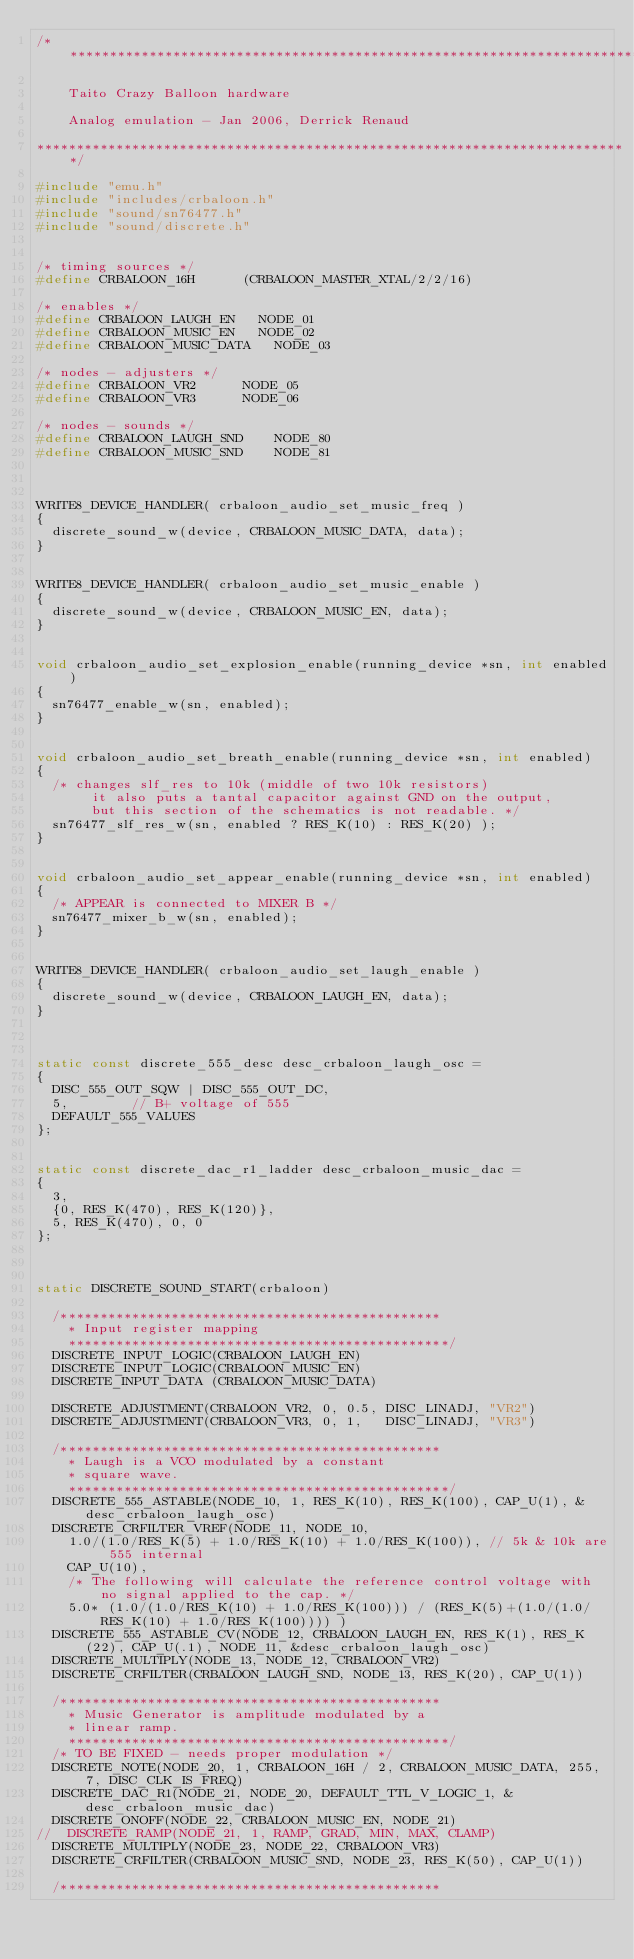<code> <loc_0><loc_0><loc_500><loc_500><_C_>/***************************************************************************

    Taito Crazy Balloon hardware

    Analog emulation - Jan 2006, Derrick Renaud

***************************************************************************/

#include "emu.h"
#include "includes/crbaloon.h"
#include "sound/sn76477.h"
#include "sound/discrete.h"


/* timing sources */
#define CRBALOON_16H			(CRBALOON_MASTER_XTAL/2/2/16)

/* enables */
#define CRBALOON_LAUGH_EN		NODE_01
#define CRBALOON_MUSIC_EN		NODE_02
#define CRBALOON_MUSIC_DATA		NODE_03

/* nodes - adjusters */
#define CRBALOON_VR2			NODE_05
#define CRBALOON_VR3			NODE_06

/* nodes - sounds */
#define CRBALOON_LAUGH_SND		NODE_80
#define CRBALOON_MUSIC_SND		NODE_81



WRITE8_DEVICE_HANDLER( crbaloon_audio_set_music_freq )
{
	discrete_sound_w(device, CRBALOON_MUSIC_DATA, data);
}


WRITE8_DEVICE_HANDLER( crbaloon_audio_set_music_enable )
{
	discrete_sound_w(device, CRBALOON_MUSIC_EN, data);
}


void crbaloon_audio_set_explosion_enable(running_device *sn, int enabled)
{
	sn76477_enable_w(sn, enabled);
}


void crbaloon_audio_set_breath_enable(running_device *sn, int enabled)
{
	/* changes slf_res to 10k (middle of two 10k resistors)
       it also puts a tantal capacitor against GND on the output,
       but this section of the schematics is not readable. */
	sn76477_slf_res_w(sn, enabled ? RES_K(10) : RES_K(20) );
}


void crbaloon_audio_set_appear_enable(running_device *sn, int enabled)
{
	/* APPEAR is connected to MIXER B */
	sn76477_mixer_b_w(sn, enabled);
}


WRITE8_DEVICE_HANDLER( crbaloon_audio_set_laugh_enable )
{
	discrete_sound_w(device, CRBALOON_LAUGH_EN, data);
}



static const discrete_555_desc desc_crbaloon_laugh_osc =
{
	DISC_555_OUT_SQW | DISC_555_OUT_DC,
	5,				// B+ voltage of 555
	DEFAULT_555_VALUES
};


static const discrete_dac_r1_ladder desc_crbaloon_music_dac =
{
	3,
	{0, RES_K(470), RES_K(120)},
	5, RES_K(470), 0, 0
};



static DISCRETE_SOUND_START(crbaloon)

	/************************************************
    * Input register mapping
    ************************************************/
	DISCRETE_INPUT_LOGIC(CRBALOON_LAUGH_EN)
	DISCRETE_INPUT_LOGIC(CRBALOON_MUSIC_EN)
	DISCRETE_INPUT_DATA (CRBALOON_MUSIC_DATA)

	DISCRETE_ADJUSTMENT(CRBALOON_VR2, 0, 0.5, DISC_LINADJ, "VR2")
	DISCRETE_ADJUSTMENT(CRBALOON_VR3, 0, 1,   DISC_LINADJ, "VR3")

	/************************************************
    * Laugh is a VCO modulated by a constant
    * square wave.
    ************************************************/
	DISCRETE_555_ASTABLE(NODE_10, 1, RES_K(10), RES_K(100), CAP_U(1), &desc_crbaloon_laugh_osc)
	DISCRETE_CRFILTER_VREF(NODE_11, NODE_10,
		1.0/(1.0/RES_K(5) + 1.0/RES_K(10) + 1.0/RES_K(100)), // 5k & 10k are 555 internal
		CAP_U(10),
		/* The following will calculate the reference control voltage with no signal applied to the cap. */
		5.0* (1.0/(1.0/RES_K(10) + 1.0/RES_K(100))) / (RES_K(5)+(1.0/(1.0/RES_K(10) + 1.0/RES_K(100)))) )
	DISCRETE_555_ASTABLE_CV(NODE_12, CRBALOON_LAUGH_EN, RES_K(1), RES_K(22), CAP_U(.1), NODE_11, &desc_crbaloon_laugh_osc)
	DISCRETE_MULTIPLY(NODE_13, NODE_12, CRBALOON_VR2)
	DISCRETE_CRFILTER(CRBALOON_LAUGH_SND, NODE_13, RES_K(20), CAP_U(1))

	/************************************************
    * Music Generator is amplitude modulated by a
    * linear ramp.
    ************************************************/
	/* TO BE FIXED - needs proper modulation */
	DISCRETE_NOTE(NODE_20, 1, CRBALOON_16H / 2, CRBALOON_MUSIC_DATA, 255, 7, DISC_CLK_IS_FREQ)
	DISCRETE_DAC_R1(NODE_21, NODE_20, DEFAULT_TTL_V_LOGIC_1, &desc_crbaloon_music_dac)
	DISCRETE_ONOFF(NODE_22, CRBALOON_MUSIC_EN, NODE_21)
//  DISCRETE_RAMP(NODE_21, 1, RAMP, GRAD, MIN, MAX, CLAMP)
	DISCRETE_MULTIPLY(NODE_23, NODE_22, CRBALOON_VR3)
	DISCRETE_CRFILTER(CRBALOON_MUSIC_SND, NODE_23, RES_K(50), CAP_U(1))

	/************************************************</code> 